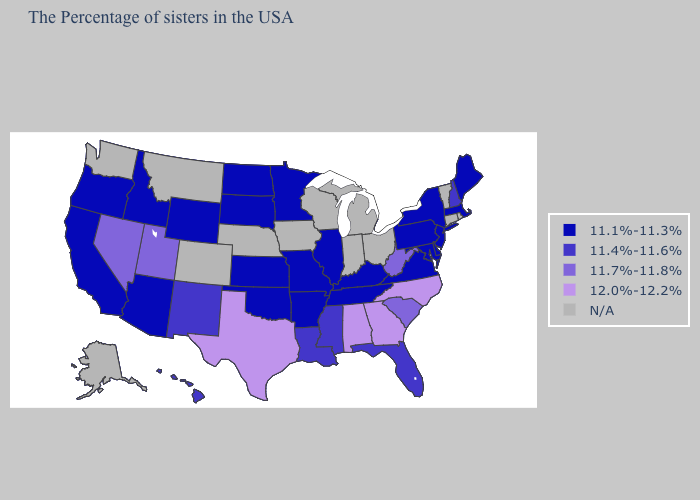Name the states that have a value in the range N/A?
Short answer required. Rhode Island, Vermont, Connecticut, Ohio, Michigan, Indiana, Wisconsin, Iowa, Nebraska, Colorado, Montana, Washington, Alaska. Does the map have missing data?
Answer briefly. Yes. Which states hav the highest value in the Northeast?
Concise answer only. New Hampshire. What is the value of New York?
Short answer required. 11.1%-11.3%. What is the highest value in the Northeast ?
Concise answer only. 11.4%-11.6%. Name the states that have a value in the range 11.7%-11.8%?
Concise answer only. South Carolina, West Virginia, Utah, Nevada. What is the lowest value in the USA?
Be succinct. 11.1%-11.3%. What is the value of Idaho?
Quick response, please. 11.1%-11.3%. Among the states that border New Mexico , which have the highest value?
Answer briefly. Texas. Does Hawaii have the lowest value in the USA?
Give a very brief answer. No. Name the states that have a value in the range N/A?
Write a very short answer. Rhode Island, Vermont, Connecticut, Ohio, Michigan, Indiana, Wisconsin, Iowa, Nebraska, Colorado, Montana, Washington, Alaska. 